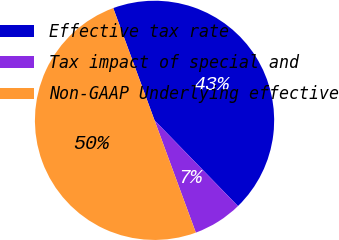<chart> <loc_0><loc_0><loc_500><loc_500><pie_chart><fcel>Effective tax rate<fcel>Tax impact of special and<fcel>Non-GAAP Underlying effective<nl><fcel>43.33%<fcel>6.67%<fcel>50.0%<nl></chart> 